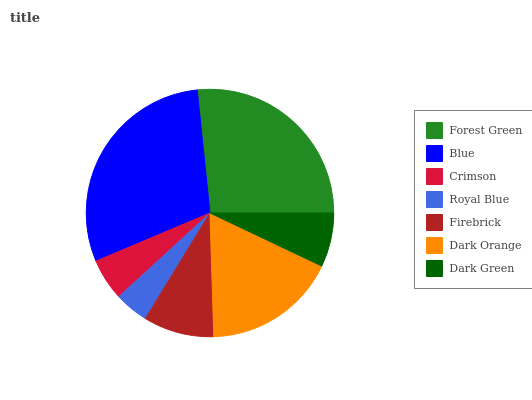Is Royal Blue the minimum?
Answer yes or no. Yes. Is Blue the maximum?
Answer yes or no. Yes. Is Crimson the minimum?
Answer yes or no. No. Is Crimson the maximum?
Answer yes or no. No. Is Blue greater than Crimson?
Answer yes or no. Yes. Is Crimson less than Blue?
Answer yes or no. Yes. Is Crimson greater than Blue?
Answer yes or no. No. Is Blue less than Crimson?
Answer yes or no. No. Is Firebrick the high median?
Answer yes or no. Yes. Is Firebrick the low median?
Answer yes or no. Yes. Is Crimson the high median?
Answer yes or no. No. Is Royal Blue the low median?
Answer yes or no. No. 